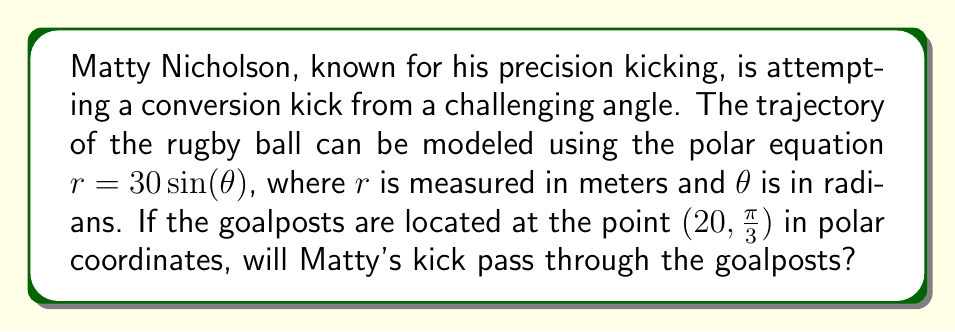Teach me how to tackle this problem. To solve this problem, we need to follow these steps:

1) First, we need to understand what the polar equation $r = 30 \sin(\theta)$ represents. This equation describes a circle with a diameter of 30 meters, centered at (0, 15) in Cartesian coordinates.

2) The goalposts are located at the point $(20, \frac{\pi}{3})$ in polar coordinates. We need to check if this point satisfies the equation of the trajectory.

3) To do this, we substitute the $\theta$ value into the equation and see if we get the corresponding $r$ value:

   $r = 30 \sin(\frac{\pi}{3})$

4) We know that $\sin(\frac{\pi}{3}) = \frac{\sqrt{3}}{2}$, so:

   $r = 30 \cdot \frac{\sqrt{3}}{2} = 15\sqrt{3} \approx 25.98$ meters

5) The $r$ value we calculated (approximately 25.98 meters) is greater than the $r$ value of the goalposts (20 meters).

6) This means that the trajectory of the ball passes beyond the goalposts.

[asy]
import graph;
size(200);
real f(real t) {return 30*sin(t);}
draw(polar(f,0,pi),blue);
dot((20*cos(pi/3),20*sin(pi/3)),red);
label("Goalposts",(20*cos(pi/3),20*sin(pi/3)),E);
draw((0,0)--(20*cos(pi/3),20*sin(pi/3)),dashed);
label("r=20",(10*cos(pi/3),10*sin(pi/3)),NW);
draw(arc((0,0),5,0,60),Arrow);
label("$\frac{\pi}{3}$",(2.5,1.5));
[/asy]
Answer: No, Matty's kick will not pass through the goalposts. The trajectory of the ball passes beyond the goalposts. 